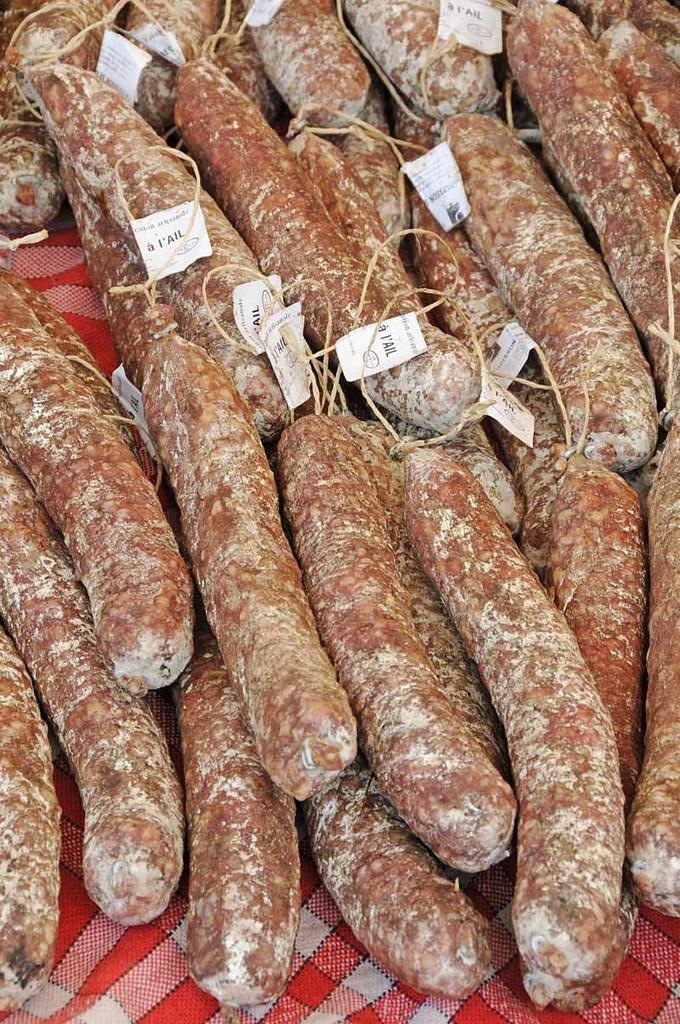What is present in the image related to food? There is food in the image. How is the food arranged or presented? The food is placed on a napkin. Are there any additional items or features related to the food? Yes, there are tags attached to the food. How many rabbits can be seen playing in the stream near the food? There are no rabbits or streams present in the image; it only features food placed on a napkin with tags attached. 